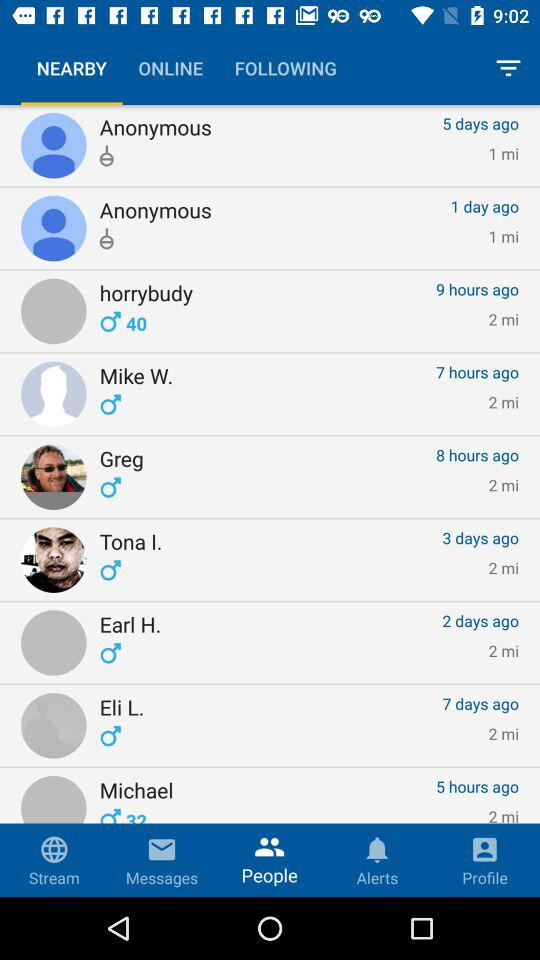How many hours ago "horrybudy" was online? "horrybudy" was online 9 hours ago. 